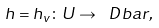<formula> <loc_0><loc_0><loc_500><loc_500>h = h _ { v } \colon U \to \ D b a r ,</formula> 